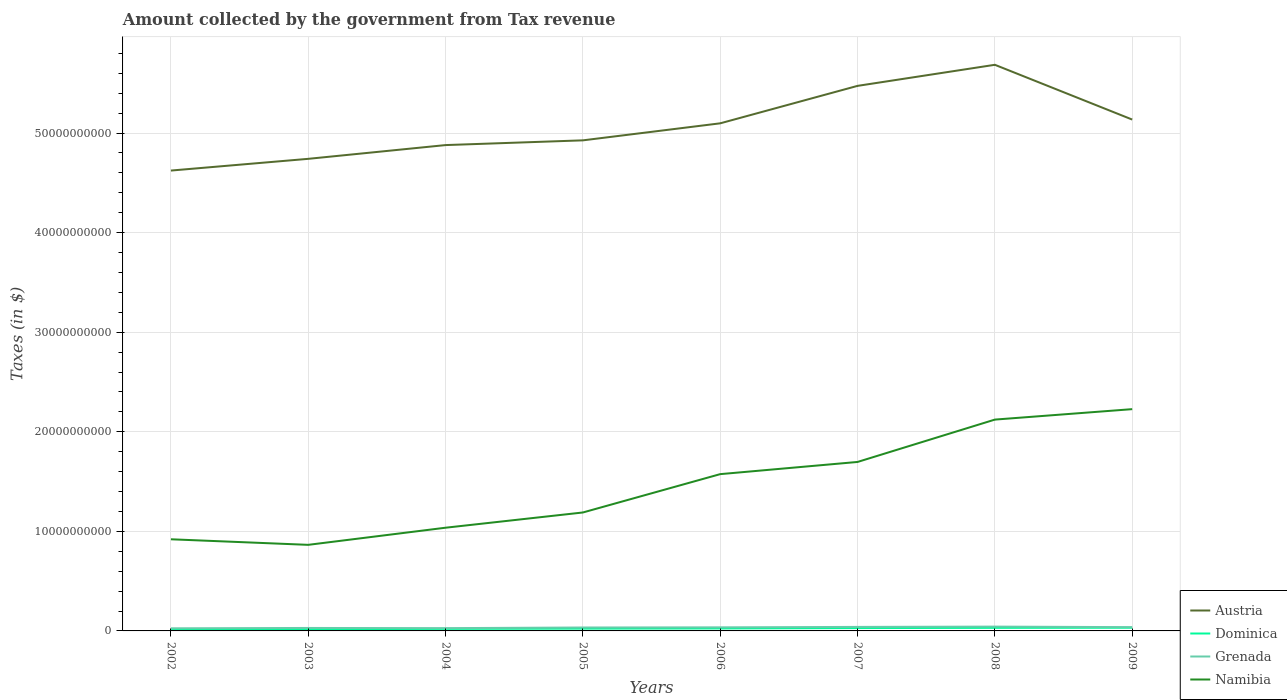How many different coloured lines are there?
Your response must be concise. 4. Is the number of lines equal to the number of legend labels?
Offer a very short reply. Yes. Across all years, what is the maximum amount collected by the government from tax revenue in Namibia?
Ensure brevity in your answer.  8.65e+09. In which year was the amount collected by the government from tax revenue in Grenada maximum?
Your response must be concise. 2002. What is the total amount collected by the government from tax revenue in Austria in the graph?
Provide a succinct answer. -2.12e+09. What is the difference between the highest and the second highest amount collected by the government from tax revenue in Austria?
Your answer should be compact. 1.06e+1. What is the difference between the highest and the lowest amount collected by the government from tax revenue in Grenada?
Make the answer very short. 4. Does the graph contain any zero values?
Provide a succinct answer. No. Where does the legend appear in the graph?
Your answer should be very brief. Bottom right. How are the legend labels stacked?
Offer a very short reply. Vertical. What is the title of the graph?
Provide a succinct answer. Amount collected by the government from Tax revenue. Does "Bosnia and Herzegovina" appear as one of the legend labels in the graph?
Make the answer very short. No. What is the label or title of the X-axis?
Provide a succinct answer. Years. What is the label or title of the Y-axis?
Keep it short and to the point. Taxes (in $). What is the Taxes (in $) in Austria in 2002?
Your answer should be very brief. 4.62e+1. What is the Taxes (in $) of Dominica in 2002?
Offer a terse response. 1.62e+08. What is the Taxes (in $) of Grenada in 2002?
Keep it short and to the point. 2.62e+08. What is the Taxes (in $) of Namibia in 2002?
Your answer should be very brief. 9.20e+09. What is the Taxes (in $) of Austria in 2003?
Provide a succinct answer. 4.74e+1. What is the Taxes (in $) of Dominica in 2003?
Your answer should be very brief. 1.79e+08. What is the Taxes (in $) in Grenada in 2003?
Ensure brevity in your answer.  2.98e+08. What is the Taxes (in $) in Namibia in 2003?
Provide a short and direct response. 8.65e+09. What is the Taxes (in $) in Austria in 2004?
Keep it short and to the point. 4.88e+1. What is the Taxes (in $) in Dominica in 2004?
Offer a very short reply. 2.05e+08. What is the Taxes (in $) of Grenada in 2004?
Your answer should be compact. 2.80e+08. What is the Taxes (in $) of Namibia in 2004?
Give a very brief answer. 1.04e+1. What is the Taxes (in $) in Austria in 2005?
Provide a short and direct response. 4.93e+1. What is the Taxes (in $) in Dominica in 2005?
Your response must be concise. 2.29e+08. What is the Taxes (in $) in Grenada in 2005?
Ensure brevity in your answer.  3.44e+08. What is the Taxes (in $) in Namibia in 2005?
Your answer should be very brief. 1.19e+1. What is the Taxes (in $) of Austria in 2006?
Provide a succinct answer. 5.10e+1. What is the Taxes (in $) of Dominica in 2006?
Offer a very short reply. 2.48e+08. What is the Taxes (in $) in Grenada in 2006?
Make the answer very short. 3.60e+08. What is the Taxes (in $) in Namibia in 2006?
Your response must be concise. 1.57e+1. What is the Taxes (in $) in Austria in 2007?
Your response must be concise. 5.47e+1. What is the Taxes (in $) in Dominica in 2007?
Give a very brief answer. 2.86e+08. What is the Taxes (in $) in Grenada in 2007?
Provide a succinct answer. 4.03e+08. What is the Taxes (in $) of Namibia in 2007?
Offer a terse response. 1.70e+1. What is the Taxes (in $) in Austria in 2008?
Your answer should be very brief. 5.69e+1. What is the Taxes (in $) of Dominica in 2008?
Your answer should be very brief. 3.07e+08. What is the Taxes (in $) of Grenada in 2008?
Offer a very short reply. 4.34e+08. What is the Taxes (in $) in Namibia in 2008?
Keep it short and to the point. 2.12e+1. What is the Taxes (in $) of Austria in 2009?
Your answer should be compact. 5.14e+1. What is the Taxes (in $) in Dominica in 2009?
Ensure brevity in your answer.  3.21e+08. What is the Taxes (in $) of Grenada in 2009?
Provide a succinct answer. 3.80e+08. What is the Taxes (in $) in Namibia in 2009?
Make the answer very short. 2.23e+1. Across all years, what is the maximum Taxes (in $) in Austria?
Give a very brief answer. 5.69e+1. Across all years, what is the maximum Taxes (in $) of Dominica?
Offer a terse response. 3.21e+08. Across all years, what is the maximum Taxes (in $) of Grenada?
Offer a terse response. 4.34e+08. Across all years, what is the maximum Taxes (in $) in Namibia?
Your answer should be compact. 2.23e+1. Across all years, what is the minimum Taxes (in $) of Austria?
Your answer should be compact. 4.62e+1. Across all years, what is the minimum Taxes (in $) in Dominica?
Give a very brief answer. 1.62e+08. Across all years, what is the minimum Taxes (in $) of Grenada?
Offer a terse response. 2.62e+08. Across all years, what is the minimum Taxes (in $) of Namibia?
Provide a succinct answer. 8.65e+09. What is the total Taxes (in $) of Austria in the graph?
Keep it short and to the point. 4.06e+11. What is the total Taxes (in $) in Dominica in the graph?
Provide a succinct answer. 1.94e+09. What is the total Taxes (in $) in Grenada in the graph?
Your answer should be compact. 2.76e+09. What is the total Taxes (in $) of Namibia in the graph?
Give a very brief answer. 1.16e+11. What is the difference between the Taxes (in $) of Austria in 2002 and that in 2003?
Provide a short and direct response. -1.18e+09. What is the difference between the Taxes (in $) in Dominica in 2002 and that in 2003?
Ensure brevity in your answer.  -1.74e+07. What is the difference between the Taxes (in $) in Grenada in 2002 and that in 2003?
Offer a terse response. -3.59e+07. What is the difference between the Taxes (in $) of Namibia in 2002 and that in 2003?
Offer a terse response. 5.58e+08. What is the difference between the Taxes (in $) of Austria in 2002 and that in 2004?
Ensure brevity in your answer.  -2.56e+09. What is the difference between the Taxes (in $) in Dominica in 2002 and that in 2004?
Your answer should be very brief. -4.32e+07. What is the difference between the Taxes (in $) in Grenada in 2002 and that in 2004?
Ensure brevity in your answer.  -1.71e+07. What is the difference between the Taxes (in $) in Namibia in 2002 and that in 2004?
Provide a succinct answer. -1.16e+09. What is the difference between the Taxes (in $) in Austria in 2002 and that in 2005?
Offer a very short reply. -3.03e+09. What is the difference between the Taxes (in $) in Dominica in 2002 and that in 2005?
Provide a succinct answer. -6.73e+07. What is the difference between the Taxes (in $) in Grenada in 2002 and that in 2005?
Your answer should be very brief. -8.15e+07. What is the difference between the Taxes (in $) in Namibia in 2002 and that in 2005?
Give a very brief answer. -2.69e+09. What is the difference between the Taxes (in $) of Austria in 2002 and that in 2006?
Give a very brief answer. -4.74e+09. What is the difference between the Taxes (in $) of Dominica in 2002 and that in 2006?
Ensure brevity in your answer.  -8.59e+07. What is the difference between the Taxes (in $) of Grenada in 2002 and that in 2006?
Your response must be concise. -9.76e+07. What is the difference between the Taxes (in $) in Namibia in 2002 and that in 2006?
Make the answer very short. -6.54e+09. What is the difference between the Taxes (in $) in Austria in 2002 and that in 2007?
Provide a succinct answer. -8.51e+09. What is the difference between the Taxes (in $) of Dominica in 2002 and that in 2007?
Ensure brevity in your answer.  -1.24e+08. What is the difference between the Taxes (in $) of Grenada in 2002 and that in 2007?
Provide a succinct answer. -1.40e+08. What is the difference between the Taxes (in $) in Namibia in 2002 and that in 2007?
Your response must be concise. -7.77e+09. What is the difference between the Taxes (in $) in Austria in 2002 and that in 2008?
Offer a terse response. -1.06e+1. What is the difference between the Taxes (in $) of Dominica in 2002 and that in 2008?
Offer a terse response. -1.45e+08. What is the difference between the Taxes (in $) in Grenada in 2002 and that in 2008?
Offer a very short reply. -1.71e+08. What is the difference between the Taxes (in $) of Namibia in 2002 and that in 2008?
Provide a short and direct response. -1.20e+1. What is the difference between the Taxes (in $) in Austria in 2002 and that in 2009?
Offer a terse response. -5.12e+09. What is the difference between the Taxes (in $) of Dominica in 2002 and that in 2009?
Provide a succinct answer. -1.59e+08. What is the difference between the Taxes (in $) in Grenada in 2002 and that in 2009?
Provide a succinct answer. -1.18e+08. What is the difference between the Taxes (in $) of Namibia in 2002 and that in 2009?
Offer a very short reply. -1.31e+1. What is the difference between the Taxes (in $) in Austria in 2003 and that in 2004?
Your response must be concise. -1.38e+09. What is the difference between the Taxes (in $) in Dominica in 2003 and that in 2004?
Your response must be concise. -2.58e+07. What is the difference between the Taxes (in $) in Grenada in 2003 and that in 2004?
Offer a terse response. 1.88e+07. What is the difference between the Taxes (in $) in Namibia in 2003 and that in 2004?
Ensure brevity in your answer.  -1.72e+09. What is the difference between the Taxes (in $) of Austria in 2003 and that in 2005?
Keep it short and to the point. -1.86e+09. What is the difference between the Taxes (in $) of Dominica in 2003 and that in 2005?
Offer a terse response. -4.99e+07. What is the difference between the Taxes (in $) in Grenada in 2003 and that in 2005?
Provide a short and direct response. -4.56e+07. What is the difference between the Taxes (in $) of Namibia in 2003 and that in 2005?
Give a very brief answer. -3.25e+09. What is the difference between the Taxes (in $) of Austria in 2003 and that in 2006?
Provide a short and direct response. -3.57e+09. What is the difference between the Taxes (in $) in Dominica in 2003 and that in 2006?
Your answer should be very brief. -6.85e+07. What is the difference between the Taxes (in $) in Grenada in 2003 and that in 2006?
Provide a succinct answer. -6.17e+07. What is the difference between the Taxes (in $) in Namibia in 2003 and that in 2006?
Ensure brevity in your answer.  -7.10e+09. What is the difference between the Taxes (in $) in Austria in 2003 and that in 2007?
Your answer should be compact. -7.33e+09. What is the difference between the Taxes (in $) of Dominica in 2003 and that in 2007?
Your answer should be very brief. -1.06e+08. What is the difference between the Taxes (in $) of Grenada in 2003 and that in 2007?
Your response must be concise. -1.04e+08. What is the difference between the Taxes (in $) in Namibia in 2003 and that in 2007?
Your response must be concise. -8.32e+09. What is the difference between the Taxes (in $) in Austria in 2003 and that in 2008?
Make the answer very short. -9.44e+09. What is the difference between the Taxes (in $) of Dominica in 2003 and that in 2008?
Provide a succinct answer. -1.28e+08. What is the difference between the Taxes (in $) of Grenada in 2003 and that in 2008?
Keep it short and to the point. -1.36e+08. What is the difference between the Taxes (in $) in Namibia in 2003 and that in 2008?
Ensure brevity in your answer.  -1.26e+1. What is the difference between the Taxes (in $) in Austria in 2003 and that in 2009?
Keep it short and to the point. -3.94e+09. What is the difference between the Taxes (in $) of Dominica in 2003 and that in 2009?
Your answer should be compact. -1.41e+08. What is the difference between the Taxes (in $) in Grenada in 2003 and that in 2009?
Ensure brevity in your answer.  -8.16e+07. What is the difference between the Taxes (in $) of Namibia in 2003 and that in 2009?
Your response must be concise. -1.36e+1. What is the difference between the Taxes (in $) of Austria in 2004 and that in 2005?
Keep it short and to the point. -4.75e+08. What is the difference between the Taxes (in $) in Dominica in 2004 and that in 2005?
Your response must be concise. -2.41e+07. What is the difference between the Taxes (in $) in Grenada in 2004 and that in 2005?
Make the answer very short. -6.44e+07. What is the difference between the Taxes (in $) of Namibia in 2004 and that in 2005?
Your answer should be compact. -1.53e+09. What is the difference between the Taxes (in $) of Austria in 2004 and that in 2006?
Your answer should be compact. -2.19e+09. What is the difference between the Taxes (in $) in Dominica in 2004 and that in 2006?
Provide a succinct answer. -4.27e+07. What is the difference between the Taxes (in $) in Grenada in 2004 and that in 2006?
Make the answer very short. -8.05e+07. What is the difference between the Taxes (in $) of Namibia in 2004 and that in 2006?
Offer a very short reply. -5.38e+09. What is the difference between the Taxes (in $) in Austria in 2004 and that in 2007?
Your answer should be compact. -5.95e+09. What is the difference between the Taxes (in $) of Dominica in 2004 and that in 2007?
Your answer should be very brief. -8.03e+07. What is the difference between the Taxes (in $) in Grenada in 2004 and that in 2007?
Give a very brief answer. -1.23e+08. What is the difference between the Taxes (in $) in Namibia in 2004 and that in 2007?
Offer a terse response. -6.60e+09. What is the difference between the Taxes (in $) of Austria in 2004 and that in 2008?
Give a very brief answer. -8.06e+09. What is the difference between the Taxes (in $) in Dominica in 2004 and that in 2008?
Your answer should be compact. -1.02e+08. What is the difference between the Taxes (in $) of Grenada in 2004 and that in 2008?
Make the answer very short. -1.54e+08. What is the difference between the Taxes (in $) of Namibia in 2004 and that in 2008?
Offer a very short reply. -1.09e+1. What is the difference between the Taxes (in $) in Austria in 2004 and that in 2009?
Your response must be concise. -2.56e+09. What is the difference between the Taxes (in $) in Dominica in 2004 and that in 2009?
Your answer should be very brief. -1.15e+08. What is the difference between the Taxes (in $) of Grenada in 2004 and that in 2009?
Ensure brevity in your answer.  -1.00e+08. What is the difference between the Taxes (in $) of Namibia in 2004 and that in 2009?
Offer a terse response. -1.19e+1. What is the difference between the Taxes (in $) of Austria in 2005 and that in 2006?
Offer a terse response. -1.71e+09. What is the difference between the Taxes (in $) in Dominica in 2005 and that in 2006?
Offer a very short reply. -1.86e+07. What is the difference between the Taxes (in $) in Grenada in 2005 and that in 2006?
Give a very brief answer. -1.61e+07. What is the difference between the Taxes (in $) of Namibia in 2005 and that in 2006?
Provide a short and direct response. -3.85e+09. What is the difference between the Taxes (in $) in Austria in 2005 and that in 2007?
Keep it short and to the point. -5.47e+09. What is the difference between the Taxes (in $) in Dominica in 2005 and that in 2007?
Your response must be concise. -5.62e+07. What is the difference between the Taxes (in $) of Grenada in 2005 and that in 2007?
Keep it short and to the point. -5.89e+07. What is the difference between the Taxes (in $) in Namibia in 2005 and that in 2007?
Your answer should be very brief. -5.07e+09. What is the difference between the Taxes (in $) in Austria in 2005 and that in 2008?
Provide a succinct answer. -7.59e+09. What is the difference between the Taxes (in $) of Dominica in 2005 and that in 2008?
Ensure brevity in your answer.  -7.81e+07. What is the difference between the Taxes (in $) of Grenada in 2005 and that in 2008?
Your answer should be very brief. -8.99e+07. What is the difference between the Taxes (in $) of Namibia in 2005 and that in 2008?
Keep it short and to the point. -9.33e+09. What is the difference between the Taxes (in $) in Austria in 2005 and that in 2009?
Your answer should be compact. -2.09e+09. What is the difference between the Taxes (in $) in Dominica in 2005 and that in 2009?
Your answer should be compact. -9.13e+07. What is the difference between the Taxes (in $) in Grenada in 2005 and that in 2009?
Provide a short and direct response. -3.60e+07. What is the difference between the Taxes (in $) in Namibia in 2005 and that in 2009?
Provide a succinct answer. -1.04e+1. What is the difference between the Taxes (in $) of Austria in 2006 and that in 2007?
Give a very brief answer. -3.76e+09. What is the difference between the Taxes (in $) in Dominica in 2006 and that in 2007?
Your answer should be very brief. -3.76e+07. What is the difference between the Taxes (in $) of Grenada in 2006 and that in 2007?
Offer a very short reply. -4.28e+07. What is the difference between the Taxes (in $) in Namibia in 2006 and that in 2007?
Ensure brevity in your answer.  -1.22e+09. What is the difference between the Taxes (in $) of Austria in 2006 and that in 2008?
Offer a very short reply. -5.88e+09. What is the difference between the Taxes (in $) of Dominica in 2006 and that in 2008?
Provide a short and direct response. -5.95e+07. What is the difference between the Taxes (in $) of Grenada in 2006 and that in 2008?
Provide a short and direct response. -7.38e+07. What is the difference between the Taxes (in $) of Namibia in 2006 and that in 2008?
Ensure brevity in your answer.  -5.48e+09. What is the difference between the Taxes (in $) in Austria in 2006 and that in 2009?
Ensure brevity in your answer.  -3.78e+08. What is the difference between the Taxes (in $) of Dominica in 2006 and that in 2009?
Keep it short and to the point. -7.27e+07. What is the difference between the Taxes (in $) in Grenada in 2006 and that in 2009?
Your answer should be very brief. -1.99e+07. What is the difference between the Taxes (in $) of Namibia in 2006 and that in 2009?
Offer a terse response. -6.53e+09. What is the difference between the Taxes (in $) in Austria in 2007 and that in 2008?
Your answer should be compact. -2.12e+09. What is the difference between the Taxes (in $) in Dominica in 2007 and that in 2008?
Keep it short and to the point. -2.19e+07. What is the difference between the Taxes (in $) of Grenada in 2007 and that in 2008?
Your response must be concise. -3.10e+07. What is the difference between the Taxes (in $) in Namibia in 2007 and that in 2008?
Provide a succinct answer. -4.25e+09. What is the difference between the Taxes (in $) of Austria in 2007 and that in 2009?
Offer a very short reply. 3.38e+09. What is the difference between the Taxes (in $) in Dominica in 2007 and that in 2009?
Make the answer very short. -3.51e+07. What is the difference between the Taxes (in $) in Grenada in 2007 and that in 2009?
Offer a very short reply. 2.29e+07. What is the difference between the Taxes (in $) of Namibia in 2007 and that in 2009?
Provide a succinct answer. -5.30e+09. What is the difference between the Taxes (in $) of Austria in 2008 and that in 2009?
Your answer should be compact. 5.50e+09. What is the difference between the Taxes (in $) in Dominica in 2008 and that in 2009?
Make the answer very short. -1.32e+07. What is the difference between the Taxes (in $) of Grenada in 2008 and that in 2009?
Keep it short and to the point. 5.39e+07. What is the difference between the Taxes (in $) in Namibia in 2008 and that in 2009?
Your response must be concise. -1.05e+09. What is the difference between the Taxes (in $) in Austria in 2002 and the Taxes (in $) in Dominica in 2003?
Offer a very short reply. 4.61e+1. What is the difference between the Taxes (in $) in Austria in 2002 and the Taxes (in $) in Grenada in 2003?
Make the answer very short. 4.59e+1. What is the difference between the Taxes (in $) of Austria in 2002 and the Taxes (in $) of Namibia in 2003?
Your response must be concise. 3.76e+1. What is the difference between the Taxes (in $) in Dominica in 2002 and the Taxes (in $) in Grenada in 2003?
Your response must be concise. -1.36e+08. What is the difference between the Taxes (in $) in Dominica in 2002 and the Taxes (in $) in Namibia in 2003?
Provide a succinct answer. -8.48e+09. What is the difference between the Taxes (in $) in Grenada in 2002 and the Taxes (in $) in Namibia in 2003?
Ensure brevity in your answer.  -8.38e+09. What is the difference between the Taxes (in $) in Austria in 2002 and the Taxes (in $) in Dominica in 2004?
Offer a terse response. 4.60e+1. What is the difference between the Taxes (in $) in Austria in 2002 and the Taxes (in $) in Grenada in 2004?
Keep it short and to the point. 4.60e+1. What is the difference between the Taxes (in $) in Austria in 2002 and the Taxes (in $) in Namibia in 2004?
Your response must be concise. 3.59e+1. What is the difference between the Taxes (in $) of Dominica in 2002 and the Taxes (in $) of Grenada in 2004?
Provide a succinct answer. -1.18e+08. What is the difference between the Taxes (in $) of Dominica in 2002 and the Taxes (in $) of Namibia in 2004?
Provide a short and direct response. -1.02e+1. What is the difference between the Taxes (in $) of Grenada in 2002 and the Taxes (in $) of Namibia in 2004?
Provide a succinct answer. -1.01e+1. What is the difference between the Taxes (in $) of Austria in 2002 and the Taxes (in $) of Dominica in 2005?
Give a very brief answer. 4.60e+1. What is the difference between the Taxes (in $) in Austria in 2002 and the Taxes (in $) in Grenada in 2005?
Provide a succinct answer. 4.59e+1. What is the difference between the Taxes (in $) in Austria in 2002 and the Taxes (in $) in Namibia in 2005?
Provide a succinct answer. 3.43e+1. What is the difference between the Taxes (in $) in Dominica in 2002 and the Taxes (in $) in Grenada in 2005?
Provide a short and direct response. -1.82e+08. What is the difference between the Taxes (in $) in Dominica in 2002 and the Taxes (in $) in Namibia in 2005?
Your response must be concise. -1.17e+1. What is the difference between the Taxes (in $) of Grenada in 2002 and the Taxes (in $) of Namibia in 2005?
Give a very brief answer. -1.16e+1. What is the difference between the Taxes (in $) of Austria in 2002 and the Taxes (in $) of Dominica in 2006?
Offer a very short reply. 4.60e+1. What is the difference between the Taxes (in $) of Austria in 2002 and the Taxes (in $) of Grenada in 2006?
Make the answer very short. 4.59e+1. What is the difference between the Taxes (in $) of Austria in 2002 and the Taxes (in $) of Namibia in 2006?
Provide a succinct answer. 3.05e+1. What is the difference between the Taxes (in $) in Dominica in 2002 and the Taxes (in $) in Grenada in 2006?
Make the answer very short. -1.98e+08. What is the difference between the Taxes (in $) of Dominica in 2002 and the Taxes (in $) of Namibia in 2006?
Offer a very short reply. -1.56e+1. What is the difference between the Taxes (in $) in Grenada in 2002 and the Taxes (in $) in Namibia in 2006?
Your answer should be compact. -1.55e+1. What is the difference between the Taxes (in $) in Austria in 2002 and the Taxes (in $) in Dominica in 2007?
Give a very brief answer. 4.59e+1. What is the difference between the Taxes (in $) in Austria in 2002 and the Taxes (in $) in Grenada in 2007?
Give a very brief answer. 4.58e+1. What is the difference between the Taxes (in $) of Austria in 2002 and the Taxes (in $) of Namibia in 2007?
Give a very brief answer. 2.93e+1. What is the difference between the Taxes (in $) of Dominica in 2002 and the Taxes (in $) of Grenada in 2007?
Your response must be concise. -2.41e+08. What is the difference between the Taxes (in $) in Dominica in 2002 and the Taxes (in $) in Namibia in 2007?
Make the answer very short. -1.68e+1. What is the difference between the Taxes (in $) of Grenada in 2002 and the Taxes (in $) of Namibia in 2007?
Offer a very short reply. -1.67e+1. What is the difference between the Taxes (in $) in Austria in 2002 and the Taxes (in $) in Dominica in 2008?
Provide a succinct answer. 4.59e+1. What is the difference between the Taxes (in $) in Austria in 2002 and the Taxes (in $) in Grenada in 2008?
Give a very brief answer. 4.58e+1. What is the difference between the Taxes (in $) in Austria in 2002 and the Taxes (in $) in Namibia in 2008?
Provide a short and direct response. 2.50e+1. What is the difference between the Taxes (in $) of Dominica in 2002 and the Taxes (in $) of Grenada in 2008?
Offer a terse response. -2.72e+08. What is the difference between the Taxes (in $) of Dominica in 2002 and the Taxes (in $) of Namibia in 2008?
Offer a terse response. -2.11e+1. What is the difference between the Taxes (in $) in Grenada in 2002 and the Taxes (in $) in Namibia in 2008?
Offer a terse response. -2.10e+1. What is the difference between the Taxes (in $) of Austria in 2002 and the Taxes (in $) of Dominica in 2009?
Keep it short and to the point. 4.59e+1. What is the difference between the Taxes (in $) in Austria in 2002 and the Taxes (in $) in Grenada in 2009?
Your answer should be very brief. 4.59e+1. What is the difference between the Taxes (in $) of Austria in 2002 and the Taxes (in $) of Namibia in 2009?
Give a very brief answer. 2.40e+1. What is the difference between the Taxes (in $) in Dominica in 2002 and the Taxes (in $) in Grenada in 2009?
Keep it short and to the point. -2.18e+08. What is the difference between the Taxes (in $) in Dominica in 2002 and the Taxes (in $) in Namibia in 2009?
Offer a terse response. -2.21e+1. What is the difference between the Taxes (in $) of Grenada in 2002 and the Taxes (in $) of Namibia in 2009?
Offer a terse response. -2.20e+1. What is the difference between the Taxes (in $) of Austria in 2003 and the Taxes (in $) of Dominica in 2004?
Make the answer very short. 4.72e+1. What is the difference between the Taxes (in $) in Austria in 2003 and the Taxes (in $) in Grenada in 2004?
Ensure brevity in your answer.  4.71e+1. What is the difference between the Taxes (in $) in Austria in 2003 and the Taxes (in $) in Namibia in 2004?
Your answer should be compact. 3.70e+1. What is the difference between the Taxes (in $) of Dominica in 2003 and the Taxes (in $) of Grenada in 2004?
Offer a terse response. -1.00e+08. What is the difference between the Taxes (in $) of Dominica in 2003 and the Taxes (in $) of Namibia in 2004?
Keep it short and to the point. -1.02e+1. What is the difference between the Taxes (in $) in Grenada in 2003 and the Taxes (in $) in Namibia in 2004?
Your answer should be compact. -1.01e+1. What is the difference between the Taxes (in $) in Austria in 2003 and the Taxes (in $) in Dominica in 2005?
Offer a terse response. 4.72e+1. What is the difference between the Taxes (in $) of Austria in 2003 and the Taxes (in $) of Grenada in 2005?
Your answer should be very brief. 4.71e+1. What is the difference between the Taxes (in $) of Austria in 2003 and the Taxes (in $) of Namibia in 2005?
Ensure brevity in your answer.  3.55e+1. What is the difference between the Taxes (in $) of Dominica in 2003 and the Taxes (in $) of Grenada in 2005?
Keep it short and to the point. -1.64e+08. What is the difference between the Taxes (in $) in Dominica in 2003 and the Taxes (in $) in Namibia in 2005?
Your answer should be compact. -1.17e+1. What is the difference between the Taxes (in $) of Grenada in 2003 and the Taxes (in $) of Namibia in 2005?
Make the answer very short. -1.16e+1. What is the difference between the Taxes (in $) in Austria in 2003 and the Taxes (in $) in Dominica in 2006?
Offer a terse response. 4.72e+1. What is the difference between the Taxes (in $) of Austria in 2003 and the Taxes (in $) of Grenada in 2006?
Keep it short and to the point. 4.71e+1. What is the difference between the Taxes (in $) of Austria in 2003 and the Taxes (in $) of Namibia in 2006?
Keep it short and to the point. 3.17e+1. What is the difference between the Taxes (in $) in Dominica in 2003 and the Taxes (in $) in Grenada in 2006?
Make the answer very short. -1.81e+08. What is the difference between the Taxes (in $) of Dominica in 2003 and the Taxes (in $) of Namibia in 2006?
Ensure brevity in your answer.  -1.56e+1. What is the difference between the Taxes (in $) of Grenada in 2003 and the Taxes (in $) of Namibia in 2006?
Ensure brevity in your answer.  -1.54e+1. What is the difference between the Taxes (in $) of Austria in 2003 and the Taxes (in $) of Dominica in 2007?
Provide a succinct answer. 4.71e+1. What is the difference between the Taxes (in $) in Austria in 2003 and the Taxes (in $) in Grenada in 2007?
Your answer should be compact. 4.70e+1. What is the difference between the Taxes (in $) in Austria in 2003 and the Taxes (in $) in Namibia in 2007?
Offer a terse response. 3.04e+1. What is the difference between the Taxes (in $) of Dominica in 2003 and the Taxes (in $) of Grenada in 2007?
Provide a short and direct response. -2.23e+08. What is the difference between the Taxes (in $) in Dominica in 2003 and the Taxes (in $) in Namibia in 2007?
Your answer should be very brief. -1.68e+1. What is the difference between the Taxes (in $) of Grenada in 2003 and the Taxes (in $) of Namibia in 2007?
Keep it short and to the point. -1.67e+1. What is the difference between the Taxes (in $) in Austria in 2003 and the Taxes (in $) in Dominica in 2008?
Make the answer very short. 4.71e+1. What is the difference between the Taxes (in $) in Austria in 2003 and the Taxes (in $) in Grenada in 2008?
Your answer should be compact. 4.70e+1. What is the difference between the Taxes (in $) of Austria in 2003 and the Taxes (in $) of Namibia in 2008?
Your answer should be compact. 2.62e+1. What is the difference between the Taxes (in $) of Dominica in 2003 and the Taxes (in $) of Grenada in 2008?
Make the answer very short. -2.54e+08. What is the difference between the Taxes (in $) of Dominica in 2003 and the Taxes (in $) of Namibia in 2008?
Offer a terse response. -2.10e+1. What is the difference between the Taxes (in $) of Grenada in 2003 and the Taxes (in $) of Namibia in 2008?
Give a very brief answer. -2.09e+1. What is the difference between the Taxes (in $) of Austria in 2003 and the Taxes (in $) of Dominica in 2009?
Provide a short and direct response. 4.71e+1. What is the difference between the Taxes (in $) of Austria in 2003 and the Taxes (in $) of Grenada in 2009?
Your response must be concise. 4.70e+1. What is the difference between the Taxes (in $) in Austria in 2003 and the Taxes (in $) in Namibia in 2009?
Provide a short and direct response. 2.51e+1. What is the difference between the Taxes (in $) in Dominica in 2003 and the Taxes (in $) in Grenada in 2009?
Provide a succinct answer. -2.00e+08. What is the difference between the Taxes (in $) in Dominica in 2003 and the Taxes (in $) in Namibia in 2009?
Provide a short and direct response. -2.21e+1. What is the difference between the Taxes (in $) of Grenada in 2003 and the Taxes (in $) of Namibia in 2009?
Ensure brevity in your answer.  -2.20e+1. What is the difference between the Taxes (in $) of Austria in 2004 and the Taxes (in $) of Dominica in 2005?
Your answer should be very brief. 4.86e+1. What is the difference between the Taxes (in $) of Austria in 2004 and the Taxes (in $) of Grenada in 2005?
Ensure brevity in your answer.  4.84e+1. What is the difference between the Taxes (in $) in Austria in 2004 and the Taxes (in $) in Namibia in 2005?
Make the answer very short. 3.69e+1. What is the difference between the Taxes (in $) of Dominica in 2004 and the Taxes (in $) of Grenada in 2005?
Give a very brief answer. -1.39e+08. What is the difference between the Taxes (in $) of Dominica in 2004 and the Taxes (in $) of Namibia in 2005?
Provide a succinct answer. -1.17e+1. What is the difference between the Taxes (in $) of Grenada in 2004 and the Taxes (in $) of Namibia in 2005?
Your answer should be compact. -1.16e+1. What is the difference between the Taxes (in $) of Austria in 2004 and the Taxes (in $) of Dominica in 2006?
Offer a very short reply. 4.85e+1. What is the difference between the Taxes (in $) of Austria in 2004 and the Taxes (in $) of Grenada in 2006?
Make the answer very short. 4.84e+1. What is the difference between the Taxes (in $) in Austria in 2004 and the Taxes (in $) in Namibia in 2006?
Make the answer very short. 3.30e+1. What is the difference between the Taxes (in $) of Dominica in 2004 and the Taxes (in $) of Grenada in 2006?
Your answer should be compact. -1.55e+08. What is the difference between the Taxes (in $) in Dominica in 2004 and the Taxes (in $) in Namibia in 2006?
Offer a terse response. -1.55e+1. What is the difference between the Taxes (in $) in Grenada in 2004 and the Taxes (in $) in Namibia in 2006?
Offer a terse response. -1.55e+1. What is the difference between the Taxes (in $) in Austria in 2004 and the Taxes (in $) in Dominica in 2007?
Offer a terse response. 4.85e+1. What is the difference between the Taxes (in $) of Austria in 2004 and the Taxes (in $) of Grenada in 2007?
Ensure brevity in your answer.  4.84e+1. What is the difference between the Taxes (in $) of Austria in 2004 and the Taxes (in $) of Namibia in 2007?
Your answer should be compact. 3.18e+1. What is the difference between the Taxes (in $) of Dominica in 2004 and the Taxes (in $) of Grenada in 2007?
Your answer should be very brief. -1.98e+08. What is the difference between the Taxes (in $) in Dominica in 2004 and the Taxes (in $) in Namibia in 2007?
Provide a short and direct response. -1.68e+1. What is the difference between the Taxes (in $) in Grenada in 2004 and the Taxes (in $) in Namibia in 2007?
Your response must be concise. -1.67e+1. What is the difference between the Taxes (in $) of Austria in 2004 and the Taxes (in $) of Dominica in 2008?
Provide a short and direct response. 4.85e+1. What is the difference between the Taxes (in $) in Austria in 2004 and the Taxes (in $) in Grenada in 2008?
Provide a short and direct response. 4.84e+1. What is the difference between the Taxes (in $) of Austria in 2004 and the Taxes (in $) of Namibia in 2008?
Your response must be concise. 2.76e+1. What is the difference between the Taxes (in $) in Dominica in 2004 and the Taxes (in $) in Grenada in 2008?
Keep it short and to the point. -2.29e+08. What is the difference between the Taxes (in $) of Dominica in 2004 and the Taxes (in $) of Namibia in 2008?
Offer a terse response. -2.10e+1. What is the difference between the Taxes (in $) of Grenada in 2004 and the Taxes (in $) of Namibia in 2008?
Provide a short and direct response. -2.09e+1. What is the difference between the Taxes (in $) of Austria in 2004 and the Taxes (in $) of Dominica in 2009?
Offer a terse response. 4.85e+1. What is the difference between the Taxes (in $) of Austria in 2004 and the Taxes (in $) of Grenada in 2009?
Provide a succinct answer. 4.84e+1. What is the difference between the Taxes (in $) in Austria in 2004 and the Taxes (in $) in Namibia in 2009?
Your answer should be compact. 2.65e+1. What is the difference between the Taxes (in $) of Dominica in 2004 and the Taxes (in $) of Grenada in 2009?
Offer a very short reply. -1.75e+08. What is the difference between the Taxes (in $) in Dominica in 2004 and the Taxes (in $) in Namibia in 2009?
Keep it short and to the point. -2.21e+1. What is the difference between the Taxes (in $) of Grenada in 2004 and the Taxes (in $) of Namibia in 2009?
Give a very brief answer. -2.20e+1. What is the difference between the Taxes (in $) in Austria in 2005 and the Taxes (in $) in Dominica in 2006?
Give a very brief answer. 4.90e+1. What is the difference between the Taxes (in $) in Austria in 2005 and the Taxes (in $) in Grenada in 2006?
Your response must be concise. 4.89e+1. What is the difference between the Taxes (in $) in Austria in 2005 and the Taxes (in $) in Namibia in 2006?
Offer a very short reply. 3.35e+1. What is the difference between the Taxes (in $) of Dominica in 2005 and the Taxes (in $) of Grenada in 2006?
Give a very brief answer. -1.31e+08. What is the difference between the Taxes (in $) of Dominica in 2005 and the Taxes (in $) of Namibia in 2006?
Provide a succinct answer. -1.55e+1. What is the difference between the Taxes (in $) of Grenada in 2005 and the Taxes (in $) of Namibia in 2006?
Give a very brief answer. -1.54e+1. What is the difference between the Taxes (in $) in Austria in 2005 and the Taxes (in $) in Dominica in 2007?
Keep it short and to the point. 4.90e+1. What is the difference between the Taxes (in $) of Austria in 2005 and the Taxes (in $) of Grenada in 2007?
Your response must be concise. 4.89e+1. What is the difference between the Taxes (in $) in Austria in 2005 and the Taxes (in $) in Namibia in 2007?
Your answer should be very brief. 3.23e+1. What is the difference between the Taxes (in $) in Dominica in 2005 and the Taxes (in $) in Grenada in 2007?
Provide a succinct answer. -1.74e+08. What is the difference between the Taxes (in $) in Dominica in 2005 and the Taxes (in $) in Namibia in 2007?
Provide a succinct answer. -1.67e+1. What is the difference between the Taxes (in $) in Grenada in 2005 and the Taxes (in $) in Namibia in 2007?
Give a very brief answer. -1.66e+1. What is the difference between the Taxes (in $) of Austria in 2005 and the Taxes (in $) of Dominica in 2008?
Your response must be concise. 4.90e+1. What is the difference between the Taxes (in $) in Austria in 2005 and the Taxes (in $) in Grenada in 2008?
Ensure brevity in your answer.  4.88e+1. What is the difference between the Taxes (in $) in Austria in 2005 and the Taxes (in $) in Namibia in 2008?
Give a very brief answer. 2.80e+1. What is the difference between the Taxes (in $) in Dominica in 2005 and the Taxes (in $) in Grenada in 2008?
Keep it short and to the point. -2.04e+08. What is the difference between the Taxes (in $) in Dominica in 2005 and the Taxes (in $) in Namibia in 2008?
Give a very brief answer. -2.10e+1. What is the difference between the Taxes (in $) in Grenada in 2005 and the Taxes (in $) in Namibia in 2008?
Offer a terse response. -2.09e+1. What is the difference between the Taxes (in $) in Austria in 2005 and the Taxes (in $) in Dominica in 2009?
Offer a very short reply. 4.89e+1. What is the difference between the Taxes (in $) in Austria in 2005 and the Taxes (in $) in Grenada in 2009?
Keep it short and to the point. 4.89e+1. What is the difference between the Taxes (in $) in Austria in 2005 and the Taxes (in $) in Namibia in 2009?
Make the answer very short. 2.70e+1. What is the difference between the Taxes (in $) in Dominica in 2005 and the Taxes (in $) in Grenada in 2009?
Keep it short and to the point. -1.51e+08. What is the difference between the Taxes (in $) in Dominica in 2005 and the Taxes (in $) in Namibia in 2009?
Provide a short and direct response. -2.20e+1. What is the difference between the Taxes (in $) of Grenada in 2005 and the Taxes (in $) of Namibia in 2009?
Provide a succinct answer. -2.19e+1. What is the difference between the Taxes (in $) in Austria in 2006 and the Taxes (in $) in Dominica in 2007?
Keep it short and to the point. 5.07e+1. What is the difference between the Taxes (in $) of Austria in 2006 and the Taxes (in $) of Grenada in 2007?
Offer a very short reply. 5.06e+1. What is the difference between the Taxes (in $) of Austria in 2006 and the Taxes (in $) of Namibia in 2007?
Keep it short and to the point. 3.40e+1. What is the difference between the Taxes (in $) of Dominica in 2006 and the Taxes (in $) of Grenada in 2007?
Offer a terse response. -1.55e+08. What is the difference between the Taxes (in $) of Dominica in 2006 and the Taxes (in $) of Namibia in 2007?
Make the answer very short. -1.67e+1. What is the difference between the Taxes (in $) in Grenada in 2006 and the Taxes (in $) in Namibia in 2007?
Your answer should be compact. -1.66e+1. What is the difference between the Taxes (in $) of Austria in 2006 and the Taxes (in $) of Dominica in 2008?
Make the answer very short. 5.07e+1. What is the difference between the Taxes (in $) of Austria in 2006 and the Taxes (in $) of Grenada in 2008?
Your answer should be compact. 5.05e+1. What is the difference between the Taxes (in $) in Austria in 2006 and the Taxes (in $) in Namibia in 2008?
Give a very brief answer. 2.98e+1. What is the difference between the Taxes (in $) in Dominica in 2006 and the Taxes (in $) in Grenada in 2008?
Give a very brief answer. -1.86e+08. What is the difference between the Taxes (in $) in Dominica in 2006 and the Taxes (in $) in Namibia in 2008?
Offer a terse response. -2.10e+1. What is the difference between the Taxes (in $) in Grenada in 2006 and the Taxes (in $) in Namibia in 2008?
Provide a succinct answer. -2.09e+1. What is the difference between the Taxes (in $) in Austria in 2006 and the Taxes (in $) in Dominica in 2009?
Your response must be concise. 5.07e+1. What is the difference between the Taxes (in $) in Austria in 2006 and the Taxes (in $) in Grenada in 2009?
Provide a short and direct response. 5.06e+1. What is the difference between the Taxes (in $) in Austria in 2006 and the Taxes (in $) in Namibia in 2009?
Your answer should be compact. 2.87e+1. What is the difference between the Taxes (in $) of Dominica in 2006 and the Taxes (in $) of Grenada in 2009?
Offer a terse response. -1.32e+08. What is the difference between the Taxes (in $) in Dominica in 2006 and the Taxes (in $) in Namibia in 2009?
Provide a short and direct response. -2.20e+1. What is the difference between the Taxes (in $) in Grenada in 2006 and the Taxes (in $) in Namibia in 2009?
Offer a terse response. -2.19e+1. What is the difference between the Taxes (in $) in Austria in 2007 and the Taxes (in $) in Dominica in 2008?
Keep it short and to the point. 5.44e+1. What is the difference between the Taxes (in $) of Austria in 2007 and the Taxes (in $) of Grenada in 2008?
Your answer should be compact. 5.43e+1. What is the difference between the Taxes (in $) in Austria in 2007 and the Taxes (in $) in Namibia in 2008?
Ensure brevity in your answer.  3.35e+1. What is the difference between the Taxes (in $) in Dominica in 2007 and the Taxes (in $) in Grenada in 2008?
Your answer should be compact. -1.48e+08. What is the difference between the Taxes (in $) in Dominica in 2007 and the Taxes (in $) in Namibia in 2008?
Ensure brevity in your answer.  -2.09e+1. What is the difference between the Taxes (in $) of Grenada in 2007 and the Taxes (in $) of Namibia in 2008?
Your answer should be very brief. -2.08e+1. What is the difference between the Taxes (in $) in Austria in 2007 and the Taxes (in $) in Dominica in 2009?
Offer a very short reply. 5.44e+1. What is the difference between the Taxes (in $) in Austria in 2007 and the Taxes (in $) in Grenada in 2009?
Your answer should be very brief. 5.44e+1. What is the difference between the Taxes (in $) in Austria in 2007 and the Taxes (in $) in Namibia in 2009?
Provide a succinct answer. 3.25e+1. What is the difference between the Taxes (in $) in Dominica in 2007 and the Taxes (in $) in Grenada in 2009?
Offer a terse response. -9.44e+07. What is the difference between the Taxes (in $) of Dominica in 2007 and the Taxes (in $) of Namibia in 2009?
Your answer should be very brief. -2.20e+1. What is the difference between the Taxes (in $) in Grenada in 2007 and the Taxes (in $) in Namibia in 2009?
Your response must be concise. -2.19e+1. What is the difference between the Taxes (in $) of Austria in 2008 and the Taxes (in $) of Dominica in 2009?
Offer a very short reply. 5.65e+1. What is the difference between the Taxes (in $) in Austria in 2008 and the Taxes (in $) in Grenada in 2009?
Provide a succinct answer. 5.65e+1. What is the difference between the Taxes (in $) of Austria in 2008 and the Taxes (in $) of Namibia in 2009?
Provide a succinct answer. 3.46e+1. What is the difference between the Taxes (in $) in Dominica in 2008 and the Taxes (in $) in Grenada in 2009?
Provide a short and direct response. -7.25e+07. What is the difference between the Taxes (in $) of Dominica in 2008 and the Taxes (in $) of Namibia in 2009?
Your answer should be very brief. -2.20e+1. What is the difference between the Taxes (in $) of Grenada in 2008 and the Taxes (in $) of Namibia in 2009?
Ensure brevity in your answer.  -2.18e+1. What is the average Taxes (in $) of Austria per year?
Make the answer very short. 5.07e+1. What is the average Taxes (in $) in Dominica per year?
Ensure brevity in your answer.  2.42e+08. What is the average Taxes (in $) of Grenada per year?
Your answer should be very brief. 3.45e+08. What is the average Taxes (in $) of Namibia per year?
Your response must be concise. 1.45e+1. In the year 2002, what is the difference between the Taxes (in $) of Austria and Taxes (in $) of Dominica?
Ensure brevity in your answer.  4.61e+1. In the year 2002, what is the difference between the Taxes (in $) of Austria and Taxes (in $) of Grenada?
Offer a very short reply. 4.60e+1. In the year 2002, what is the difference between the Taxes (in $) of Austria and Taxes (in $) of Namibia?
Your answer should be very brief. 3.70e+1. In the year 2002, what is the difference between the Taxes (in $) of Dominica and Taxes (in $) of Grenada?
Keep it short and to the point. -1.00e+08. In the year 2002, what is the difference between the Taxes (in $) in Dominica and Taxes (in $) in Namibia?
Ensure brevity in your answer.  -9.04e+09. In the year 2002, what is the difference between the Taxes (in $) of Grenada and Taxes (in $) of Namibia?
Offer a very short reply. -8.94e+09. In the year 2003, what is the difference between the Taxes (in $) of Austria and Taxes (in $) of Dominica?
Provide a succinct answer. 4.72e+1. In the year 2003, what is the difference between the Taxes (in $) in Austria and Taxes (in $) in Grenada?
Offer a very short reply. 4.71e+1. In the year 2003, what is the difference between the Taxes (in $) in Austria and Taxes (in $) in Namibia?
Make the answer very short. 3.88e+1. In the year 2003, what is the difference between the Taxes (in $) of Dominica and Taxes (in $) of Grenada?
Your answer should be very brief. -1.19e+08. In the year 2003, what is the difference between the Taxes (in $) of Dominica and Taxes (in $) of Namibia?
Offer a terse response. -8.47e+09. In the year 2003, what is the difference between the Taxes (in $) in Grenada and Taxes (in $) in Namibia?
Keep it short and to the point. -8.35e+09. In the year 2004, what is the difference between the Taxes (in $) of Austria and Taxes (in $) of Dominica?
Offer a terse response. 4.86e+1. In the year 2004, what is the difference between the Taxes (in $) in Austria and Taxes (in $) in Grenada?
Offer a terse response. 4.85e+1. In the year 2004, what is the difference between the Taxes (in $) of Austria and Taxes (in $) of Namibia?
Offer a terse response. 3.84e+1. In the year 2004, what is the difference between the Taxes (in $) in Dominica and Taxes (in $) in Grenada?
Give a very brief answer. -7.43e+07. In the year 2004, what is the difference between the Taxes (in $) in Dominica and Taxes (in $) in Namibia?
Offer a very short reply. -1.02e+1. In the year 2004, what is the difference between the Taxes (in $) in Grenada and Taxes (in $) in Namibia?
Give a very brief answer. -1.01e+1. In the year 2005, what is the difference between the Taxes (in $) in Austria and Taxes (in $) in Dominica?
Offer a terse response. 4.90e+1. In the year 2005, what is the difference between the Taxes (in $) of Austria and Taxes (in $) of Grenada?
Ensure brevity in your answer.  4.89e+1. In the year 2005, what is the difference between the Taxes (in $) of Austria and Taxes (in $) of Namibia?
Give a very brief answer. 3.74e+1. In the year 2005, what is the difference between the Taxes (in $) in Dominica and Taxes (in $) in Grenada?
Offer a terse response. -1.15e+08. In the year 2005, what is the difference between the Taxes (in $) in Dominica and Taxes (in $) in Namibia?
Keep it short and to the point. -1.17e+1. In the year 2005, what is the difference between the Taxes (in $) of Grenada and Taxes (in $) of Namibia?
Provide a short and direct response. -1.16e+1. In the year 2006, what is the difference between the Taxes (in $) of Austria and Taxes (in $) of Dominica?
Give a very brief answer. 5.07e+1. In the year 2006, what is the difference between the Taxes (in $) of Austria and Taxes (in $) of Grenada?
Offer a terse response. 5.06e+1. In the year 2006, what is the difference between the Taxes (in $) of Austria and Taxes (in $) of Namibia?
Your answer should be compact. 3.52e+1. In the year 2006, what is the difference between the Taxes (in $) in Dominica and Taxes (in $) in Grenada?
Ensure brevity in your answer.  -1.12e+08. In the year 2006, what is the difference between the Taxes (in $) in Dominica and Taxes (in $) in Namibia?
Give a very brief answer. -1.55e+1. In the year 2006, what is the difference between the Taxes (in $) of Grenada and Taxes (in $) of Namibia?
Offer a very short reply. -1.54e+1. In the year 2007, what is the difference between the Taxes (in $) of Austria and Taxes (in $) of Dominica?
Ensure brevity in your answer.  5.45e+1. In the year 2007, what is the difference between the Taxes (in $) in Austria and Taxes (in $) in Grenada?
Offer a terse response. 5.43e+1. In the year 2007, what is the difference between the Taxes (in $) in Austria and Taxes (in $) in Namibia?
Give a very brief answer. 3.78e+1. In the year 2007, what is the difference between the Taxes (in $) of Dominica and Taxes (in $) of Grenada?
Provide a succinct answer. -1.17e+08. In the year 2007, what is the difference between the Taxes (in $) of Dominica and Taxes (in $) of Namibia?
Ensure brevity in your answer.  -1.67e+1. In the year 2007, what is the difference between the Taxes (in $) of Grenada and Taxes (in $) of Namibia?
Give a very brief answer. -1.66e+1. In the year 2008, what is the difference between the Taxes (in $) in Austria and Taxes (in $) in Dominica?
Offer a terse response. 5.65e+1. In the year 2008, what is the difference between the Taxes (in $) in Austria and Taxes (in $) in Grenada?
Provide a short and direct response. 5.64e+1. In the year 2008, what is the difference between the Taxes (in $) of Austria and Taxes (in $) of Namibia?
Your answer should be very brief. 3.56e+1. In the year 2008, what is the difference between the Taxes (in $) of Dominica and Taxes (in $) of Grenada?
Your answer should be compact. -1.26e+08. In the year 2008, what is the difference between the Taxes (in $) of Dominica and Taxes (in $) of Namibia?
Give a very brief answer. -2.09e+1. In the year 2008, what is the difference between the Taxes (in $) in Grenada and Taxes (in $) in Namibia?
Give a very brief answer. -2.08e+1. In the year 2009, what is the difference between the Taxes (in $) in Austria and Taxes (in $) in Dominica?
Your answer should be very brief. 5.10e+1. In the year 2009, what is the difference between the Taxes (in $) in Austria and Taxes (in $) in Grenada?
Keep it short and to the point. 5.10e+1. In the year 2009, what is the difference between the Taxes (in $) in Austria and Taxes (in $) in Namibia?
Give a very brief answer. 2.91e+1. In the year 2009, what is the difference between the Taxes (in $) in Dominica and Taxes (in $) in Grenada?
Give a very brief answer. -5.93e+07. In the year 2009, what is the difference between the Taxes (in $) in Dominica and Taxes (in $) in Namibia?
Make the answer very short. -2.20e+1. In the year 2009, what is the difference between the Taxes (in $) of Grenada and Taxes (in $) of Namibia?
Your answer should be very brief. -2.19e+1. What is the ratio of the Taxes (in $) of Austria in 2002 to that in 2003?
Your response must be concise. 0.98. What is the ratio of the Taxes (in $) of Dominica in 2002 to that in 2003?
Offer a very short reply. 0.9. What is the ratio of the Taxes (in $) in Grenada in 2002 to that in 2003?
Make the answer very short. 0.88. What is the ratio of the Taxes (in $) of Namibia in 2002 to that in 2003?
Provide a succinct answer. 1.06. What is the ratio of the Taxes (in $) in Austria in 2002 to that in 2004?
Your response must be concise. 0.95. What is the ratio of the Taxes (in $) of Dominica in 2002 to that in 2004?
Give a very brief answer. 0.79. What is the ratio of the Taxes (in $) in Grenada in 2002 to that in 2004?
Provide a short and direct response. 0.94. What is the ratio of the Taxes (in $) in Namibia in 2002 to that in 2004?
Offer a terse response. 0.89. What is the ratio of the Taxes (in $) in Austria in 2002 to that in 2005?
Ensure brevity in your answer.  0.94. What is the ratio of the Taxes (in $) of Dominica in 2002 to that in 2005?
Provide a succinct answer. 0.71. What is the ratio of the Taxes (in $) of Grenada in 2002 to that in 2005?
Provide a short and direct response. 0.76. What is the ratio of the Taxes (in $) in Namibia in 2002 to that in 2005?
Your answer should be very brief. 0.77. What is the ratio of the Taxes (in $) of Austria in 2002 to that in 2006?
Offer a terse response. 0.91. What is the ratio of the Taxes (in $) of Dominica in 2002 to that in 2006?
Give a very brief answer. 0.65. What is the ratio of the Taxes (in $) in Grenada in 2002 to that in 2006?
Provide a short and direct response. 0.73. What is the ratio of the Taxes (in $) of Namibia in 2002 to that in 2006?
Your answer should be compact. 0.58. What is the ratio of the Taxes (in $) of Austria in 2002 to that in 2007?
Offer a very short reply. 0.84. What is the ratio of the Taxes (in $) in Dominica in 2002 to that in 2007?
Your response must be concise. 0.57. What is the ratio of the Taxes (in $) in Grenada in 2002 to that in 2007?
Your answer should be very brief. 0.65. What is the ratio of the Taxes (in $) of Namibia in 2002 to that in 2007?
Provide a short and direct response. 0.54. What is the ratio of the Taxes (in $) in Austria in 2002 to that in 2008?
Offer a very short reply. 0.81. What is the ratio of the Taxes (in $) of Dominica in 2002 to that in 2008?
Ensure brevity in your answer.  0.53. What is the ratio of the Taxes (in $) in Grenada in 2002 to that in 2008?
Offer a very short reply. 0.6. What is the ratio of the Taxes (in $) in Namibia in 2002 to that in 2008?
Ensure brevity in your answer.  0.43. What is the ratio of the Taxes (in $) in Austria in 2002 to that in 2009?
Give a very brief answer. 0.9. What is the ratio of the Taxes (in $) of Dominica in 2002 to that in 2009?
Ensure brevity in your answer.  0.51. What is the ratio of the Taxes (in $) in Grenada in 2002 to that in 2009?
Keep it short and to the point. 0.69. What is the ratio of the Taxes (in $) in Namibia in 2002 to that in 2009?
Ensure brevity in your answer.  0.41. What is the ratio of the Taxes (in $) in Austria in 2003 to that in 2004?
Offer a terse response. 0.97. What is the ratio of the Taxes (in $) in Dominica in 2003 to that in 2004?
Your answer should be compact. 0.87. What is the ratio of the Taxes (in $) in Grenada in 2003 to that in 2004?
Provide a succinct answer. 1.07. What is the ratio of the Taxes (in $) of Namibia in 2003 to that in 2004?
Offer a terse response. 0.83. What is the ratio of the Taxes (in $) of Austria in 2003 to that in 2005?
Keep it short and to the point. 0.96. What is the ratio of the Taxes (in $) of Dominica in 2003 to that in 2005?
Ensure brevity in your answer.  0.78. What is the ratio of the Taxes (in $) of Grenada in 2003 to that in 2005?
Offer a very short reply. 0.87. What is the ratio of the Taxes (in $) in Namibia in 2003 to that in 2005?
Your response must be concise. 0.73. What is the ratio of the Taxes (in $) in Dominica in 2003 to that in 2006?
Offer a terse response. 0.72. What is the ratio of the Taxes (in $) in Grenada in 2003 to that in 2006?
Provide a succinct answer. 0.83. What is the ratio of the Taxes (in $) in Namibia in 2003 to that in 2006?
Provide a succinct answer. 0.55. What is the ratio of the Taxes (in $) in Austria in 2003 to that in 2007?
Keep it short and to the point. 0.87. What is the ratio of the Taxes (in $) in Dominica in 2003 to that in 2007?
Ensure brevity in your answer.  0.63. What is the ratio of the Taxes (in $) in Grenada in 2003 to that in 2007?
Give a very brief answer. 0.74. What is the ratio of the Taxes (in $) in Namibia in 2003 to that in 2007?
Your answer should be very brief. 0.51. What is the ratio of the Taxes (in $) of Austria in 2003 to that in 2008?
Provide a short and direct response. 0.83. What is the ratio of the Taxes (in $) of Dominica in 2003 to that in 2008?
Offer a very short reply. 0.58. What is the ratio of the Taxes (in $) of Grenada in 2003 to that in 2008?
Offer a terse response. 0.69. What is the ratio of the Taxes (in $) in Namibia in 2003 to that in 2008?
Give a very brief answer. 0.41. What is the ratio of the Taxes (in $) in Austria in 2003 to that in 2009?
Provide a short and direct response. 0.92. What is the ratio of the Taxes (in $) in Dominica in 2003 to that in 2009?
Your answer should be very brief. 0.56. What is the ratio of the Taxes (in $) of Grenada in 2003 to that in 2009?
Your response must be concise. 0.79. What is the ratio of the Taxes (in $) of Namibia in 2003 to that in 2009?
Ensure brevity in your answer.  0.39. What is the ratio of the Taxes (in $) of Austria in 2004 to that in 2005?
Make the answer very short. 0.99. What is the ratio of the Taxes (in $) in Dominica in 2004 to that in 2005?
Provide a succinct answer. 0.89. What is the ratio of the Taxes (in $) of Grenada in 2004 to that in 2005?
Ensure brevity in your answer.  0.81. What is the ratio of the Taxes (in $) in Namibia in 2004 to that in 2005?
Your response must be concise. 0.87. What is the ratio of the Taxes (in $) in Austria in 2004 to that in 2006?
Provide a succinct answer. 0.96. What is the ratio of the Taxes (in $) of Dominica in 2004 to that in 2006?
Keep it short and to the point. 0.83. What is the ratio of the Taxes (in $) of Grenada in 2004 to that in 2006?
Offer a terse response. 0.78. What is the ratio of the Taxes (in $) of Namibia in 2004 to that in 2006?
Keep it short and to the point. 0.66. What is the ratio of the Taxes (in $) of Austria in 2004 to that in 2007?
Your answer should be very brief. 0.89. What is the ratio of the Taxes (in $) of Dominica in 2004 to that in 2007?
Your response must be concise. 0.72. What is the ratio of the Taxes (in $) in Grenada in 2004 to that in 2007?
Make the answer very short. 0.69. What is the ratio of the Taxes (in $) in Namibia in 2004 to that in 2007?
Provide a succinct answer. 0.61. What is the ratio of the Taxes (in $) in Austria in 2004 to that in 2008?
Your answer should be compact. 0.86. What is the ratio of the Taxes (in $) of Dominica in 2004 to that in 2008?
Your answer should be compact. 0.67. What is the ratio of the Taxes (in $) of Grenada in 2004 to that in 2008?
Provide a short and direct response. 0.64. What is the ratio of the Taxes (in $) of Namibia in 2004 to that in 2008?
Make the answer very short. 0.49. What is the ratio of the Taxes (in $) of Austria in 2004 to that in 2009?
Provide a succinct answer. 0.95. What is the ratio of the Taxes (in $) of Dominica in 2004 to that in 2009?
Make the answer very short. 0.64. What is the ratio of the Taxes (in $) of Grenada in 2004 to that in 2009?
Provide a succinct answer. 0.74. What is the ratio of the Taxes (in $) of Namibia in 2004 to that in 2009?
Your answer should be compact. 0.47. What is the ratio of the Taxes (in $) of Austria in 2005 to that in 2006?
Your response must be concise. 0.97. What is the ratio of the Taxes (in $) of Dominica in 2005 to that in 2006?
Your answer should be very brief. 0.93. What is the ratio of the Taxes (in $) of Grenada in 2005 to that in 2006?
Your response must be concise. 0.96. What is the ratio of the Taxes (in $) of Namibia in 2005 to that in 2006?
Your answer should be compact. 0.76. What is the ratio of the Taxes (in $) of Dominica in 2005 to that in 2007?
Your answer should be compact. 0.8. What is the ratio of the Taxes (in $) in Grenada in 2005 to that in 2007?
Ensure brevity in your answer.  0.85. What is the ratio of the Taxes (in $) of Namibia in 2005 to that in 2007?
Keep it short and to the point. 0.7. What is the ratio of the Taxes (in $) of Austria in 2005 to that in 2008?
Offer a terse response. 0.87. What is the ratio of the Taxes (in $) in Dominica in 2005 to that in 2008?
Your response must be concise. 0.75. What is the ratio of the Taxes (in $) in Grenada in 2005 to that in 2008?
Ensure brevity in your answer.  0.79. What is the ratio of the Taxes (in $) in Namibia in 2005 to that in 2008?
Provide a short and direct response. 0.56. What is the ratio of the Taxes (in $) in Austria in 2005 to that in 2009?
Offer a very short reply. 0.96. What is the ratio of the Taxes (in $) in Dominica in 2005 to that in 2009?
Ensure brevity in your answer.  0.72. What is the ratio of the Taxes (in $) in Grenada in 2005 to that in 2009?
Offer a terse response. 0.91. What is the ratio of the Taxes (in $) of Namibia in 2005 to that in 2009?
Keep it short and to the point. 0.53. What is the ratio of the Taxes (in $) in Austria in 2006 to that in 2007?
Offer a very short reply. 0.93. What is the ratio of the Taxes (in $) in Dominica in 2006 to that in 2007?
Your response must be concise. 0.87. What is the ratio of the Taxes (in $) of Grenada in 2006 to that in 2007?
Your response must be concise. 0.89. What is the ratio of the Taxes (in $) in Namibia in 2006 to that in 2007?
Your response must be concise. 0.93. What is the ratio of the Taxes (in $) of Austria in 2006 to that in 2008?
Provide a short and direct response. 0.9. What is the ratio of the Taxes (in $) in Dominica in 2006 to that in 2008?
Ensure brevity in your answer.  0.81. What is the ratio of the Taxes (in $) in Grenada in 2006 to that in 2008?
Your response must be concise. 0.83. What is the ratio of the Taxes (in $) in Namibia in 2006 to that in 2008?
Offer a very short reply. 0.74. What is the ratio of the Taxes (in $) in Dominica in 2006 to that in 2009?
Your answer should be compact. 0.77. What is the ratio of the Taxes (in $) of Grenada in 2006 to that in 2009?
Offer a very short reply. 0.95. What is the ratio of the Taxes (in $) of Namibia in 2006 to that in 2009?
Provide a succinct answer. 0.71. What is the ratio of the Taxes (in $) in Austria in 2007 to that in 2008?
Provide a succinct answer. 0.96. What is the ratio of the Taxes (in $) in Dominica in 2007 to that in 2008?
Your answer should be compact. 0.93. What is the ratio of the Taxes (in $) of Grenada in 2007 to that in 2008?
Provide a short and direct response. 0.93. What is the ratio of the Taxes (in $) in Namibia in 2007 to that in 2008?
Provide a succinct answer. 0.8. What is the ratio of the Taxes (in $) of Austria in 2007 to that in 2009?
Offer a terse response. 1.07. What is the ratio of the Taxes (in $) in Dominica in 2007 to that in 2009?
Give a very brief answer. 0.89. What is the ratio of the Taxes (in $) in Grenada in 2007 to that in 2009?
Your response must be concise. 1.06. What is the ratio of the Taxes (in $) of Namibia in 2007 to that in 2009?
Your answer should be very brief. 0.76. What is the ratio of the Taxes (in $) of Austria in 2008 to that in 2009?
Provide a succinct answer. 1.11. What is the ratio of the Taxes (in $) of Dominica in 2008 to that in 2009?
Ensure brevity in your answer.  0.96. What is the ratio of the Taxes (in $) of Grenada in 2008 to that in 2009?
Provide a succinct answer. 1.14. What is the ratio of the Taxes (in $) in Namibia in 2008 to that in 2009?
Keep it short and to the point. 0.95. What is the difference between the highest and the second highest Taxes (in $) of Austria?
Provide a short and direct response. 2.12e+09. What is the difference between the highest and the second highest Taxes (in $) in Dominica?
Your answer should be compact. 1.32e+07. What is the difference between the highest and the second highest Taxes (in $) in Grenada?
Provide a short and direct response. 3.10e+07. What is the difference between the highest and the second highest Taxes (in $) in Namibia?
Make the answer very short. 1.05e+09. What is the difference between the highest and the lowest Taxes (in $) in Austria?
Make the answer very short. 1.06e+1. What is the difference between the highest and the lowest Taxes (in $) in Dominica?
Your response must be concise. 1.59e+08. What is the difference between the highest and the lowest Taxes (in $) in Grenada?
Offer a terse response. 1.71e+08. What is the difference between the highest and the lowest Taxes (in $) in Namibia?
Provide a succinct answer. 1.36e+1. 